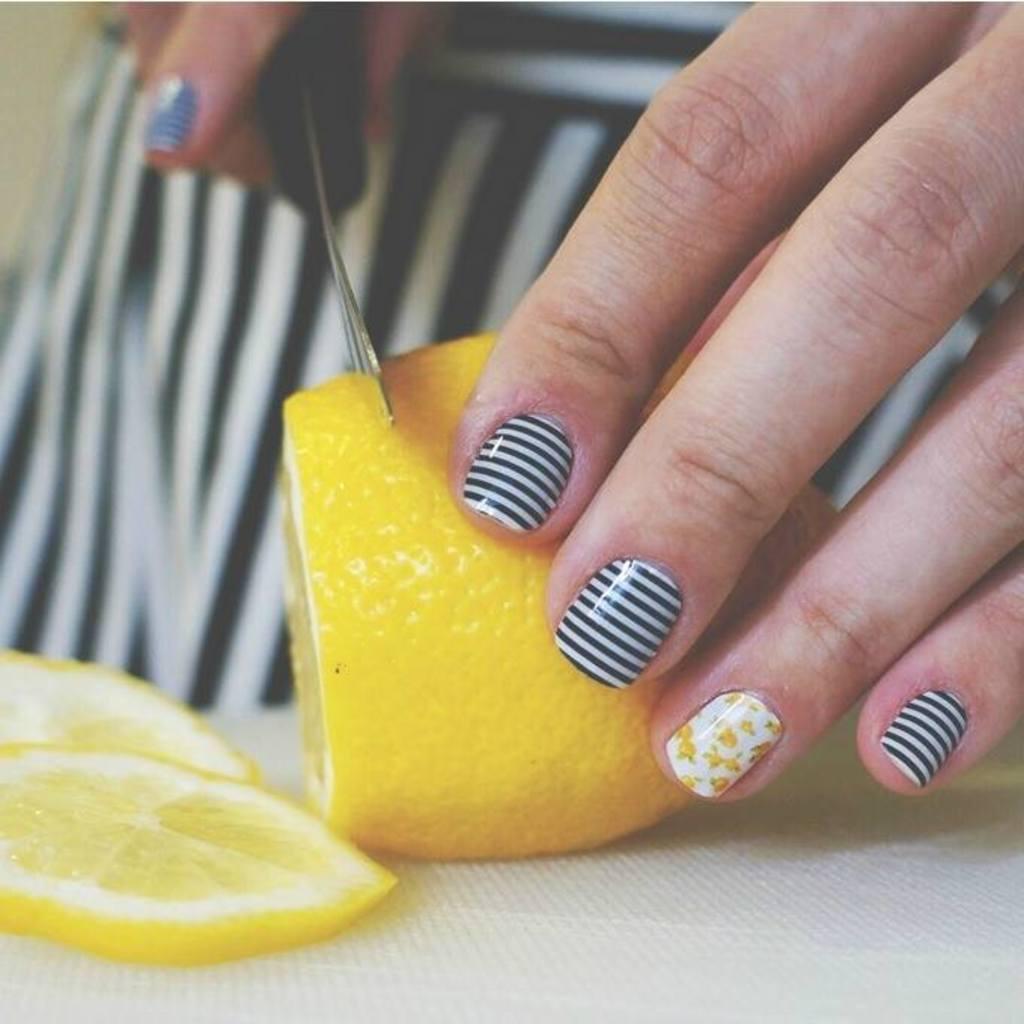Can you describe this image briefly? In this image we can see some woman slicing the yellow color fruit which is on the surface. 